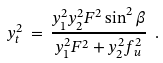<formula> <loc_0><loc_0><loc_500><loc_500>y _ { t } ^ { 2 } \, = \, \frac { y _ { 1 } ^ { 2 } y _ { 2 } ^ { 2 } F ^ { 2 } \sin ^ { 2 } \beta } { y _ { 1 } ^ { 2 } F ^ { 2 } + y _ { 2 } ^ { 2 } f _ { u } ^ { 2 } } \ .</formula> 